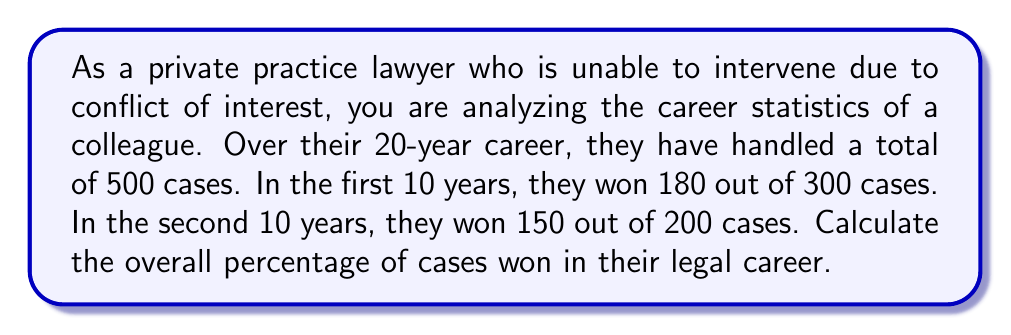Help me with this question. To solve this problem, we need to follow these steps:

1. Calculate the total number of cases won:
   First 10 years: 180 cases
   Second 10 years: 150 cases
   Total cases won = $180 + 150 = 330$ cases

2. Recall the total number of cases handled:
   Total cases = 500

3. Calculate the percentage of cases won:
   Percentage = $\frac{\text{Number of cases won}}{\text{Total number of cases}} \times 100\%$

   $$ \text{Percentage} = \frac{330}{500} \times 100\% $$

4. Simplify the fraction:
   $$ \frac{330}{500} = \frac{33}{50} = 0.66 $$

5. Calculate the final percentage:
   $$ 0.66 \times 100\% = 66\% $$

Therefore, the overall percentage of cases won in the colleague's legal career is 66%.
Answer: 66% 